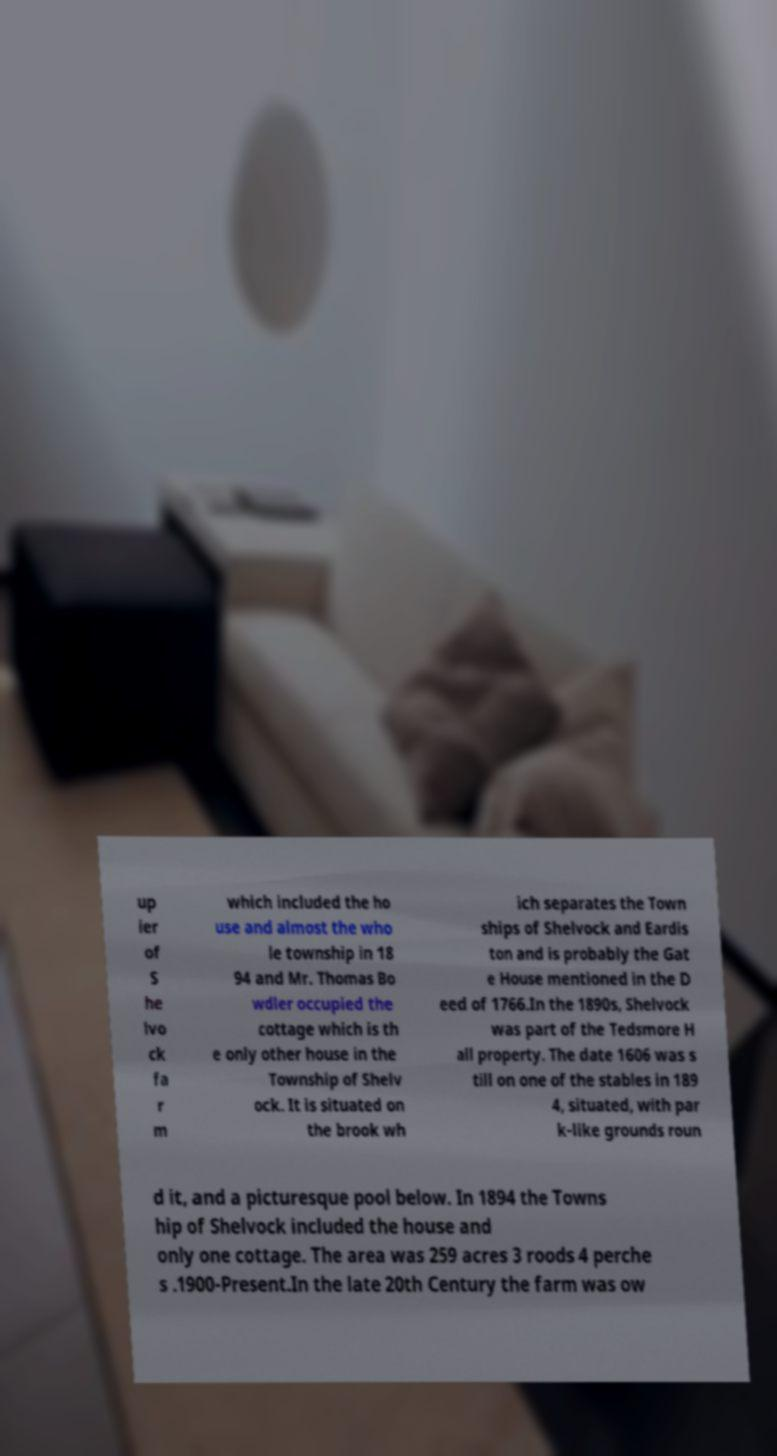I need the written content from this picture converted into text. Can you do that? up ier of S he lvo ck fa r m which included the ho use and almost the who le township in 18 94 and Mr. Thomas Bo wdler occupied the cottage which is th e only other house in the Township of Shelv ock. It is situated on the brook wh ich separates the Town ships of Shelvock and Eardis ton and is probably the Gat e House mentioned in the D eed of 1766.In the 1890s, Shelvock was part of the Tedsmore H all property. The date 1606 was s till on one of the stables in 189 4, situated, with par k-like grounds roun d it, and a picturesque pool below. In 1894 the Towns hip of Shelvock included the house and only one cottage. The area was 259 acres 3 roods 4 perche s .1900-Present.In the late 20th Century the farm was ow 